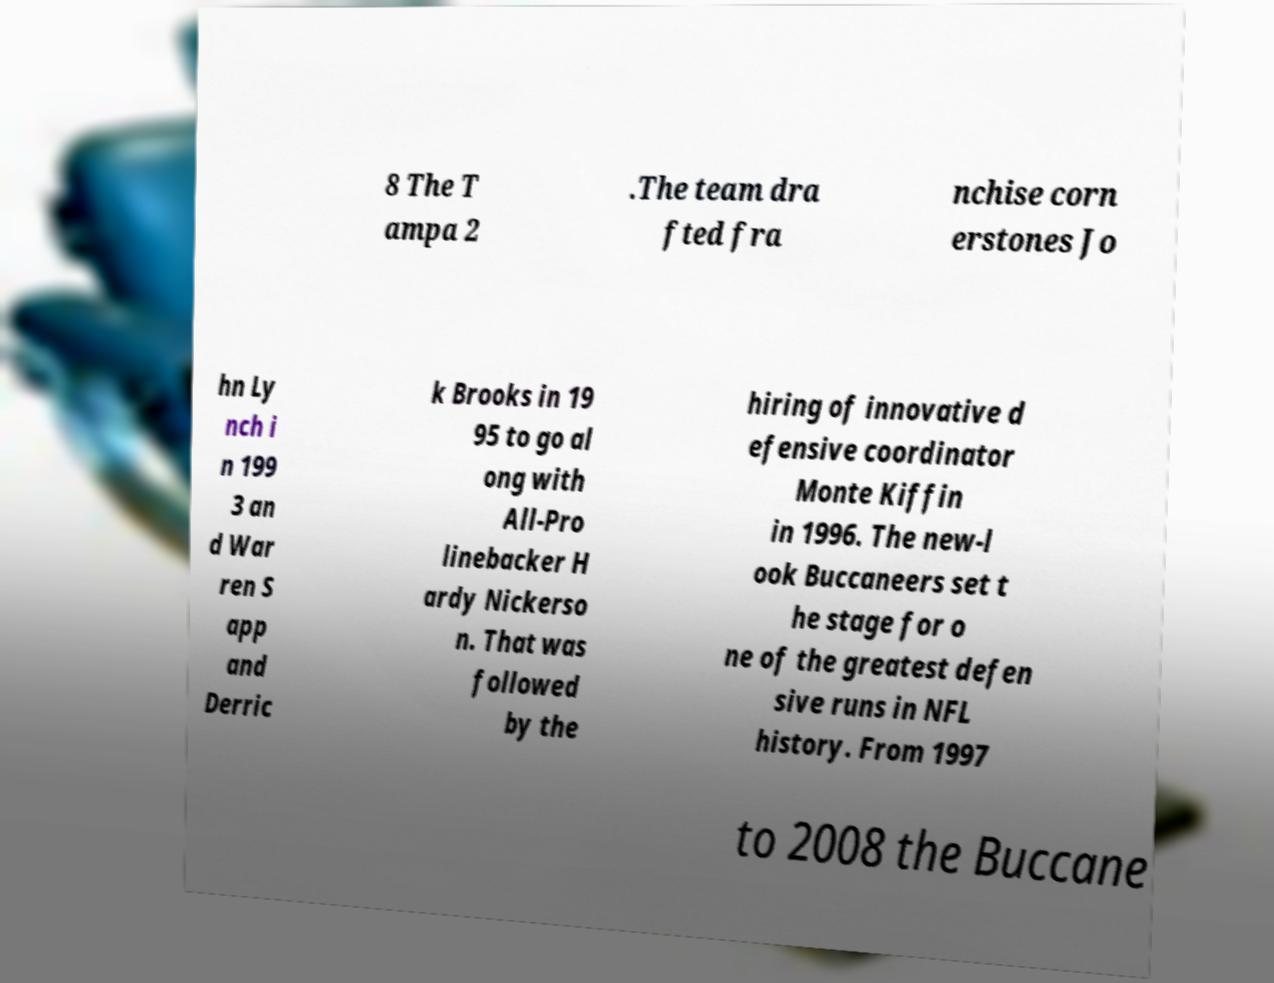There's text embedded in this image that I need extracted. Can you transcribe it verbatim? 8 The T ampa 2 .The team dra fted fra nchise corn erstones Jo hn Ly nch i n 199 3 an d War ren S app and Derric k Brooks in 19 95 to go al ong with All-Pro linebacker H ardy Nickerso n. That was followed by the hiring of innovative d efensive coordinator Monte Kiffin in 1996. The new-l ook Buccaneers set t he stage for o ne of the greatest defen sive runs in NFL history. From 1997 to 2008 the Buccane 